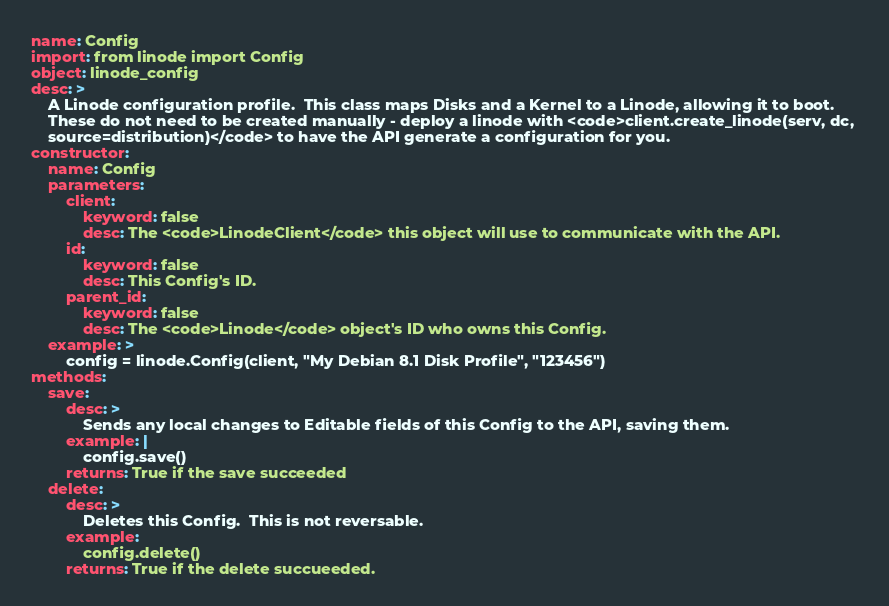Convert code to text. <code><loc_0><loc_0><loc_500><loc_500><_YAML_>name: Config
import: from linode import Config
object: linode_config
desc: >
    A Linode configuration profile.  This class maps Disks and a Kernel to a Linode, allowing it to boot.
    These do not need to be created manually - deploy a linode with <code>client.create_linode(serv, dc, 
    source=distribution)</code> to have the API generate a configuration for you.
constructor:
    name: Config
    parameters:
        client:
            keyword: false
            desc: The <code>LinodeClient</code> this object will use to communicate with the API.
        id:
            keyword: false
            desc: This Config's ID.
        parent_id:
            keyword: false
            desc: The <code>Linode</code> object's ID who owns this Config.
    example: >
        config = linode.Config(client, "My Debian 8.1 Disk Profile", "123456")
methods:
    save:
        desc: >
            Sends any local changes to Editable fields of this Config to the API, saving them.
        example: |
            config.save()
        returns: True if the save succeeded
    delete:
        desc: >
            Deletes this Config.  This is not reversable.
        example:
            config.delete()
        returns: True if the delete succueeded.
</code> 